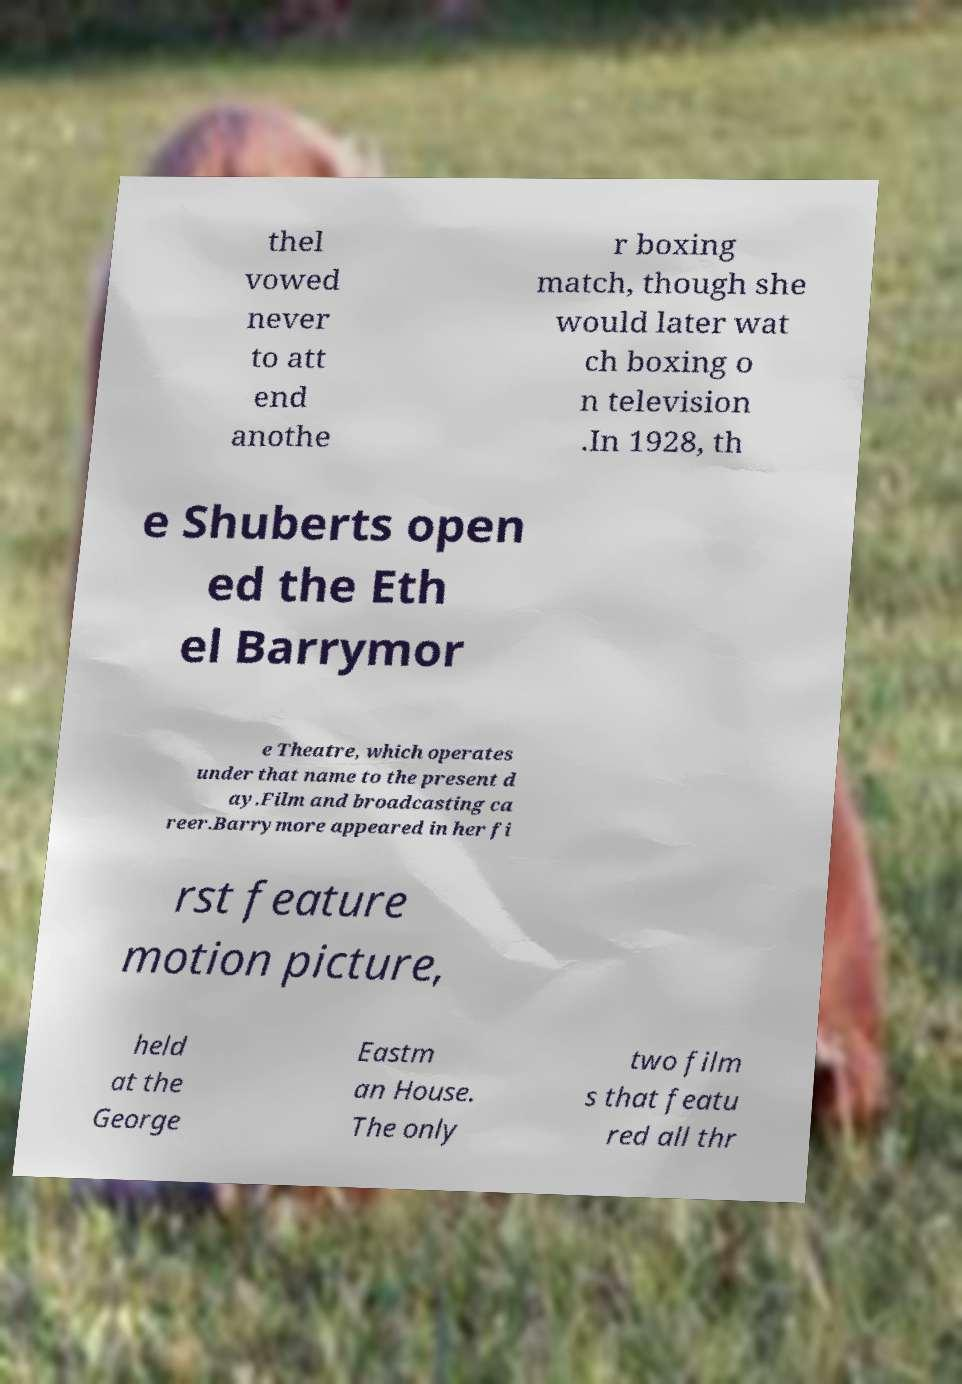Can you read and provide the text displayed in the image?This photo seems to have some interesting text. Can you extract and type it out for me? thel vowed never to att end anothe r boxing match, though she would later wat ch boxing o n television .In 1928, th e Shuberts open ed the Eth el Barrymor e Theatre, which operates under that name to the present d ay.Film and broadcasting ca reer.Barrymore appeared in her fi rst feature motion picture, held at the George Eastm an House. The only two film s that featu red all thr 